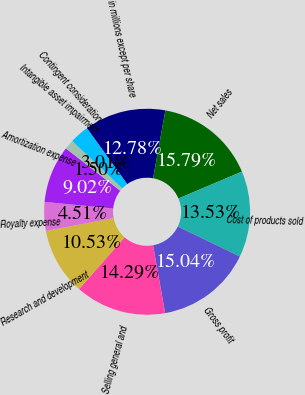Convert chart to OTSL. <chart><loc_0><loc_0><loc_500><loc_500><pie_chart><fcel>in millions except per share<fcel>Net sales<fcel>Cost of products sold<fcel>Gross profit<fcel>Selling general and<fcel>Research and development<fcel>Royalty expense<fcel>Amortization expense<fcel>Intangible asset impairment<fcel>Contingent consideration<nl><fcel>12.78%<fcel>15.79%<fcel>13.53%<fcel>15.04%<fcel>14.29%<fcel>10.53%<fcel>4.51%<fcel>9.02%<fcel>1.5%<fcel>3.01%<nl></chart> 